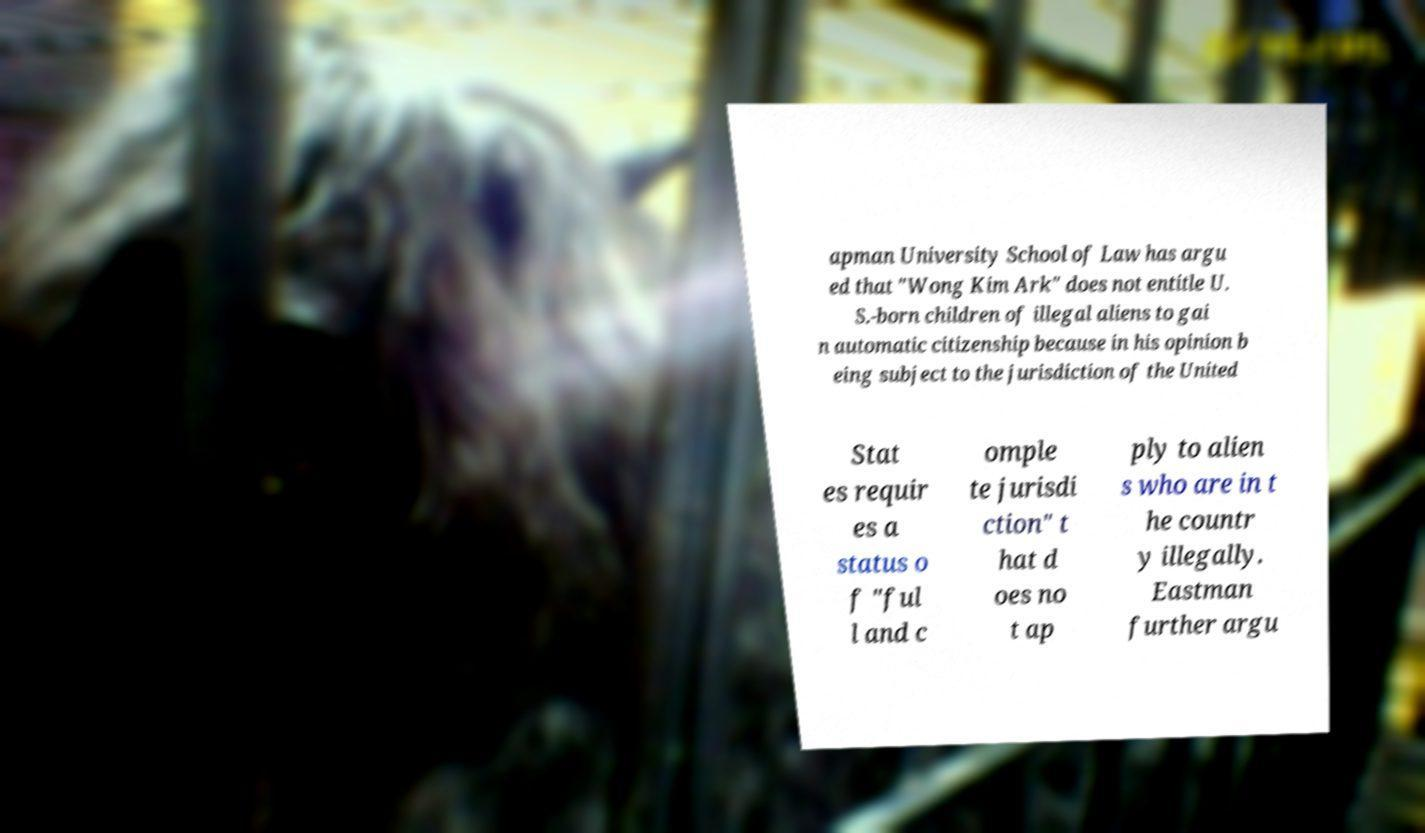There's text embedded in this image that I need extracted. Can you transcribe it verbatim? apman University School of Law has argu ed that "Wong Kim Ark" does not entitle U. S.-born children of illegal aliens to gai n automatic citizenship because in his opinion b eing subject to the jurisdiction of the United Stat es requir es a status o f "ful l and c omple te jurisdi ction" t hat d oes no t ap ply to alien s who are in t he countr y illegally. Eastman further argu 